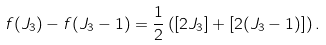<formula> <loc_0><loc_0><loc_500><loc_500>f ( J _ { 3 } ) - f ( J _ { 3 } - 1 ) = \frac { 1 } { 2 } \left ( [ 2 J _ { 3 } ] + [ 2 ( J _ { 3 } - 1 ) ] \right ) .</formula> 